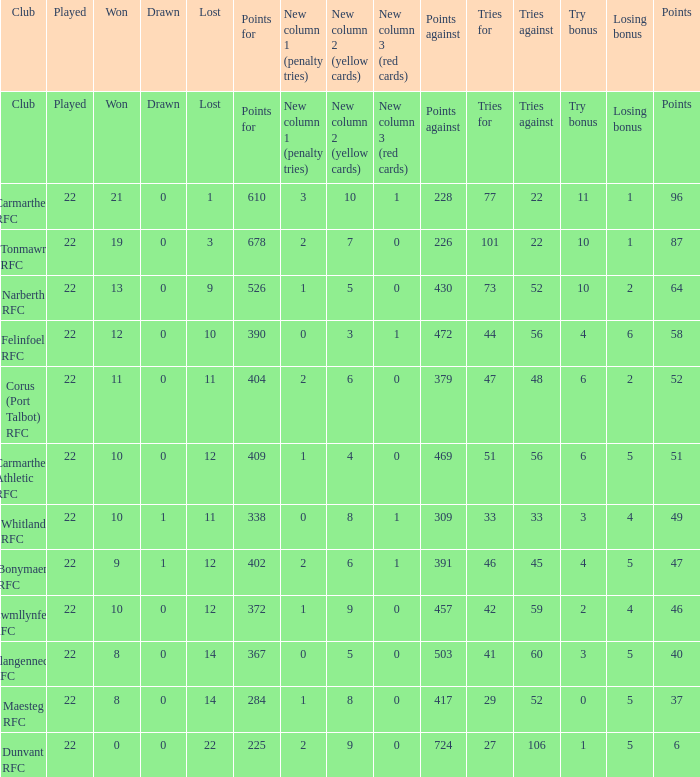Name the tries against for drawn 1.0. 